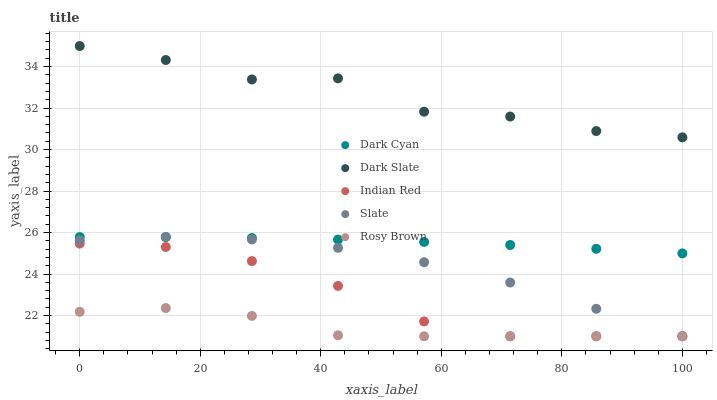Does Rosy Brown have the minimum area under the curve?
Answer yes or no. Yes. Does Dark Slate have the maximum area under the curve?
Answer yes or no. Yes. Does Slate have the minimum area under the curve?
Answer yes or no. No. Does Slate have the maximum area under the curve?
Answer yes or no. No. Is Dark Cyan the smoothest?
Answer yes or no. Yes. Is Dark Slate the roughest?
Answer yes or no. Yes. Is Slate the smoothest?
Answer yes or no. No. Is Slate the roughest?
Answer yes or no. No. Does Slate have the lowest value?
Answer yes or no. Yes. Does Dark Slate have the lowest value?
Answer yes or no. No. Does Dark Slate have the highest value?
Answer yes or no. Yes. Does Slate have the highest value?
Answer yes or no. No. Is Rosy Brown less than Dark Slate?
Answer yes or no. Yes. Is Dark Cyan greater than Indian Red?
Answer yes or no. Yes. Does Slate intersect Dark Cyan?
Answer yes or no. Yes. Is Slate less than Dark Cyan?
Answer yes or no. No. Is Slate greater than Dark Cyan?
Answer yes or no. No. Does Rosy Brown intersect Dark Slate?
Answer yes or no. No. 